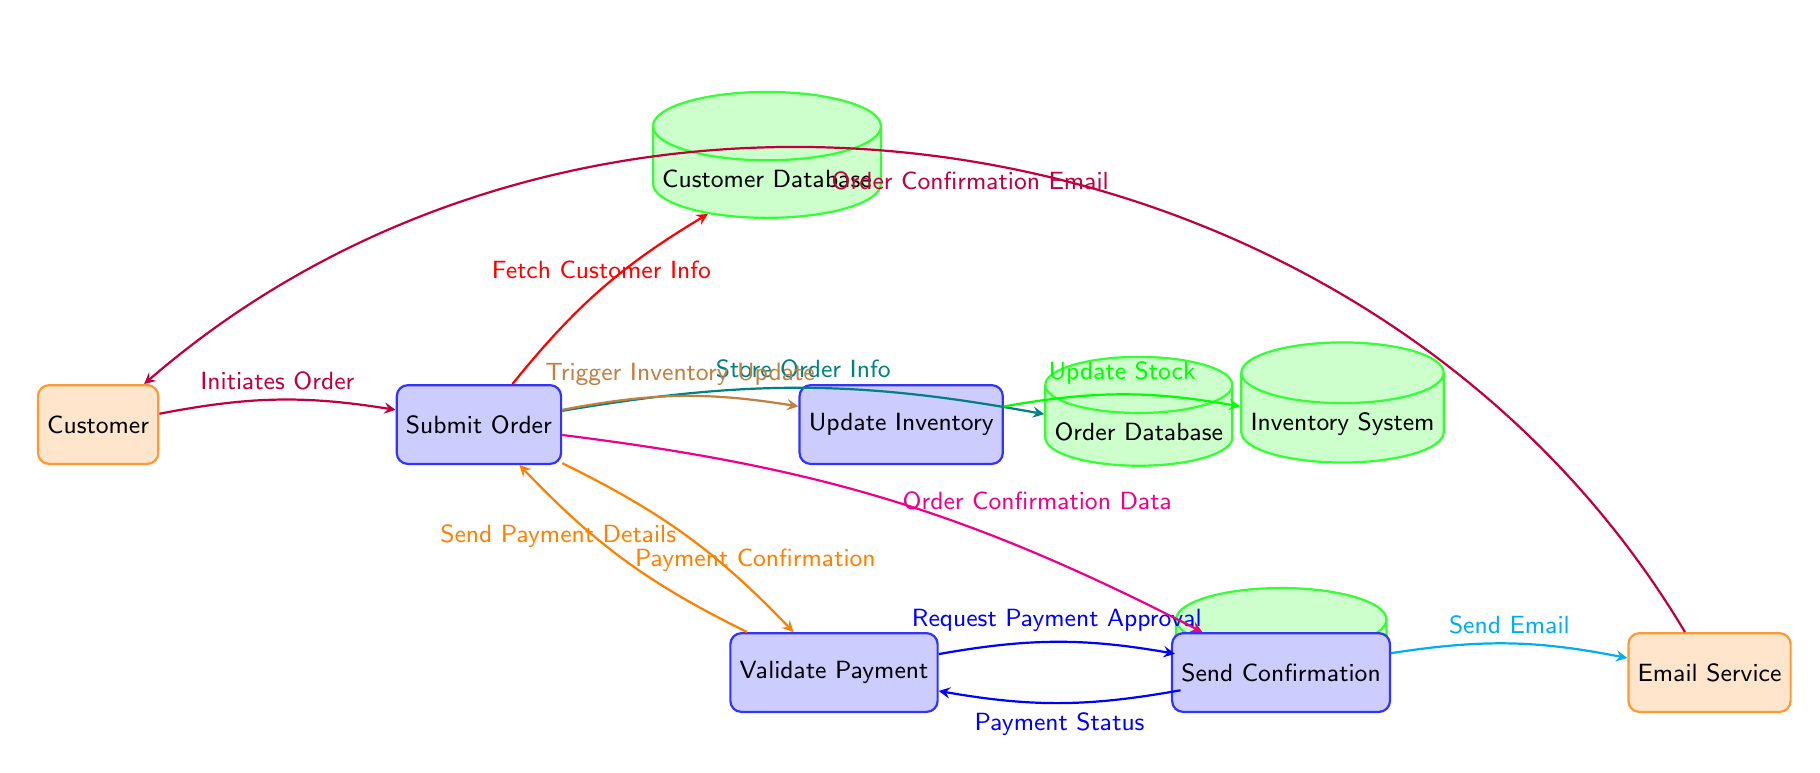What is the starting point of the process? The starting point of the process is the node labeled "Customer," which represents the user initiating the online purchase.
Answer: Customer How many processes are represented in the diagram? There are four process nodes: "Submit Order," "Validate Payment," "Update Inventory," and "Send Confirmation." Thus, the total count is four.
Answer: 4 What action does the customer take first? The customer first initiates the order, which is shown by the arrow pointing from "Customer" to "Submit Order."
Answer: Initiates Order Which database is used to store order information? The order information is stored in the "Order Database," as indicated by the flow from "Submit Order" to "Order Database."
Answer: Order Database How does the payment get validated? The payment gets validated through the process node "Validate Payment," which requests payment approval from the "Payment Gateway."
Answer: Validate Payment What is sent after confirming the order? After confirming the order, the "Email Service" sends out the order confirmation email to the customer, as shown by the arrow leading from "Send Confirmation" to "Email Service."
Answer: Order Confirmation Email What is the purpose of the "Update Inventory" process? The "Update Inventory" process is triggered after the order submission to ensure the stock levels are adjusted accordingly, as indicated by the arrow leading from "Submit Order" to "Update Inventory."
Answer: Trigger Inventory Update What does the "Payment Gateway" provide back to the validation process? The "Payment Gateway" returns the "Payment Status" back to the "Validate Payment" process after processing the payment information, which is represented by the arrow pointing from "Payment Gateway" to "Validate Payment."
Answer: Payment Status What type of diagram is this? This is a data flow diagram, which depicts the flow of data between the customer and various backend processes relevant to an online purchase.
Answer: Data Flow Diagram 